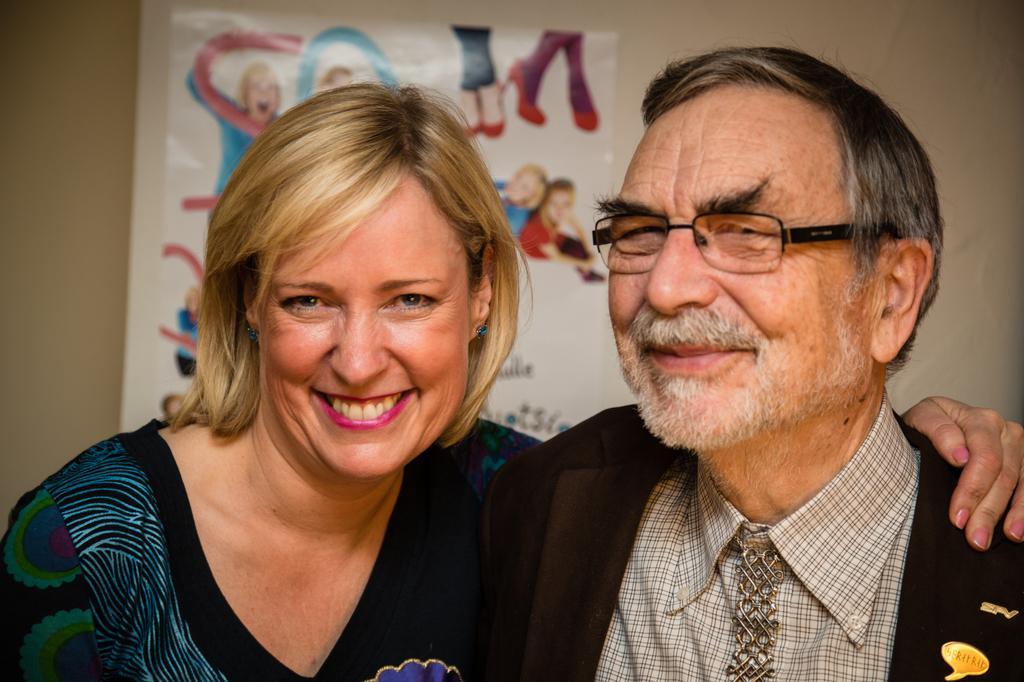Could you give a brief overview of what you see in this image? In the picture I can see a man and a woman are smiling. In the background I can see a poster attached to the wall. 